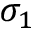Convert formula to latex. <formula><loc_0><loc_0><loc_500><loc_500>\sigma _ { 1 }</formula> 